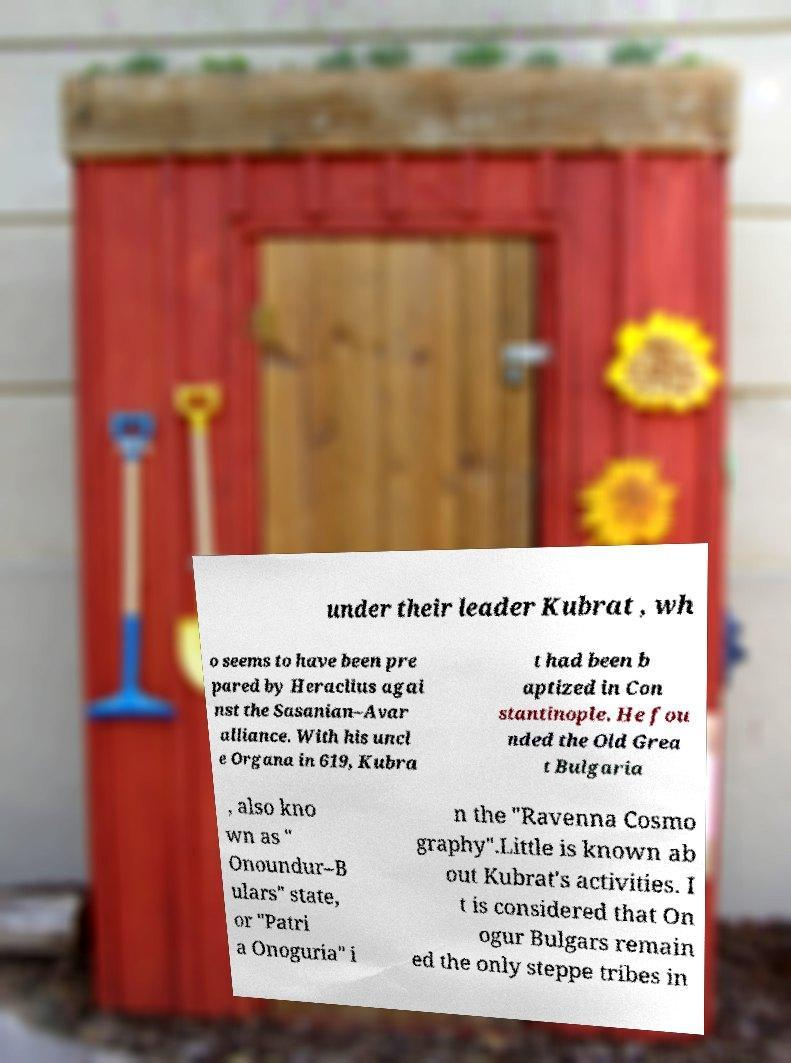What messages or text are displayed in this image? I need them in a readable, typed format. under their leader Kubrat , wh o seems to have been pre pared by Heraclius agai nst the Sasanian–Avar alliance. With his uncl e Organa in 619, Kubra t had been b aptized in Con stantinople. He fou nded the Old Grea t Bulgaria , also kno wn as " Onoundur–B ulars" state, or "Patri a Onoguria" i n the "Ravenna Cosmo graphy".Little is known ab out Kubrat's activities. I t is considered that On ogur Bulgars remain ed the only steppe tribes in 